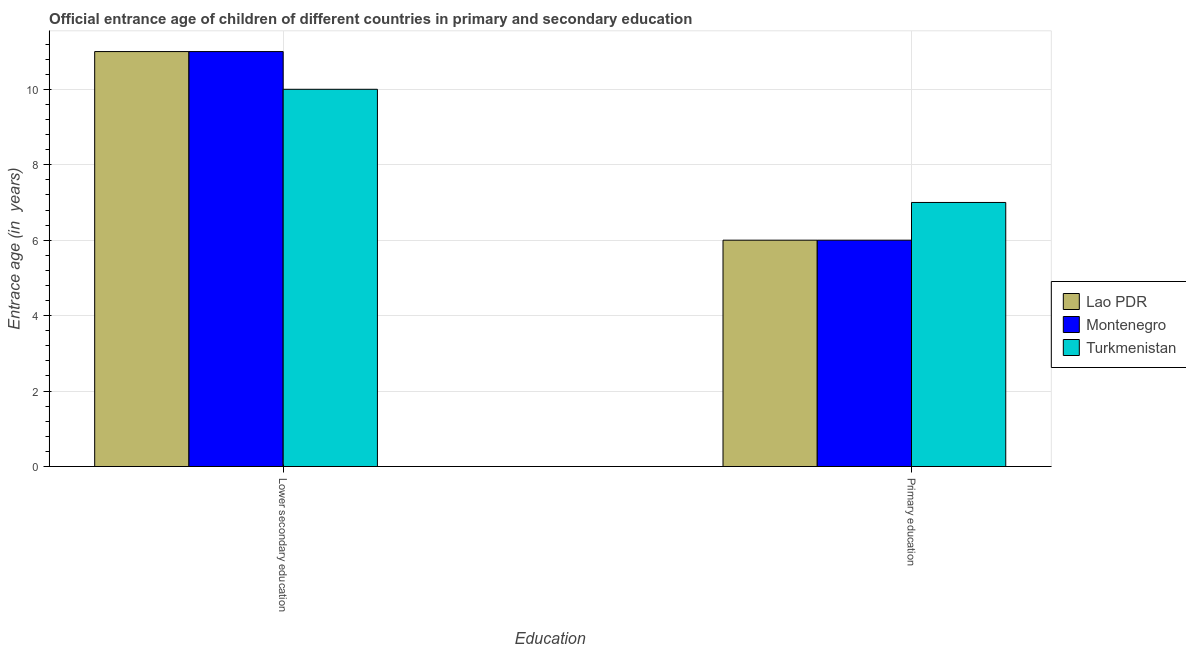How many groups of bars are there?
Ensure brevity in your answer.  2. Are the number of bars per tick equal to the number of legend labels?
Offer a terse response. Yes. Are the number of bars on each tick of the X-axis equal?
Provide a short and direct response. Yes. What is the label of the 1st group of bars from the left?
Ensure brevity in your answer.  Lower secondary education. What is the entrance age of chiildren in primary education in Turkmenistan?
Provide a succinct answer. 7. Across all countries, what is the maximum entrance age of children in lower secondary education?
Your response must be concise. 11. Across all countries, what is the minimum entrance age of children in lower secondary education?
Provide a succinct answer. 10. In which country was the entrance age of chiildren in primary education maximum?
Your answer should be compact. Turkmenistan. In which country was the entrance age of children in lower secondary education minimum?
Keep it short and to the point. Turkmenistan. What is the total entrance age of children in lower secondary education in the graph?
Ensure brevity in your answer.  32. What is the difference between the entrance age of chiildren in primary education in Lao PDR and that in Turkmenistan?
Your response must be concise. -1. What is the difference between the entrance age of children in lower secondary education in Lao PDR and the entrance age of chiildren in primary education in Turkmenistan?
Offer a terse response. 4. What is the average entrance age of children in lower secondary education per country?
Offer a terse response. 10.67. What is the difference between the entrance age of chiildren in primary education and entrance age of children in lower secondary education in Lao PDR?
Provide a succinct answer. -5. What does the 2nd bar from the left in Primary education represents?
Give a very brief answer. Montenegro. What does the 1st bar from the right in Lower secondary education represents?
Offer a very short reply. Turkmenistan. Are all the bars in the graph horizontal?
Keep it short and to the point. No. Are the values on the major ticks of Y-axis written in scientific E-notation?
Offer a very short reply. No. How many legend labels are there?
Keep it short and to the point. 3. What is the title of the graph?
Your response must be concise. Official entrance age of children of different countries in primary and secondary education. Does "Pacific island small states" appear as one of the legend labels in the graph?
Offer a very short reply. No. What is the label or title of the X-axis?
Ensure brevity in your answer.  Education. What is the label or title of the Y-axis?
Your response must be concise. Entrace age (in  years). What is the Entrace age (in  years) of Lao PDR in Lower secondary education?
Keep it short and to the point. 11. What is the Entrace age (in  years) in Montenegro in Lower secondary education?
Offer a very short reply. 11. What is the Entrace age (in  years) of Lao PDR in Primary education?
Ensure brevity in your answer.  6. What is the Entrace age (in  years) in Turkmenistan in Primary education?
Offer a very short reply. 7. Across all Education, what is the maximum Entrace age (in  years) in Lao PDR?
Your response must be concise. 11. Across all Education, what is the maximum Entrace age (in  years) of Montenegro?
Your answer should be compact. 11. Across all Education, what is the maximum Entrace age (in  years) in Turkmenistan?
Provide a short and direct response. 10. Across all Education, what is the minimum Entrace age (in  years) of Lao PDR?
Give a very brief answer. 6. Across all Education, what is the minimum Entrace age (in  years) of Montenegro?
Provide a succinct answer. 6. Across all Education, what is the minimum Entrace age (in  years) in Turkmenistan?
Make the answer very short. 7. What is the total Entrace age (in  years) in Montenegro in the graph?
Keep it short and to the point. 17. What is the difference between the Entrace age (in  years) in Montenegro in Lower secondary education and that in Primary education?
Make the answer very short. 5. What is the difference between the Entrace age (in  years) of Lao PDR in Lower secondary education and the Entrace age (in  years) of Turkmenistan in Primary education?
Your answer should be compact. 4. What is the difference between the Entrace age (in  years) of Montenegro in Lower secondary education and the Entrace age (in  years) of Turkmenistan in Primary education?
Your answer should be compact. 4. What is the average Entrace age (in  years) of Turkmenistan per Education?
Your response must be concise. 8.5. What is the difference between the Entrace age (in  years) in Lao PDR and Entrace age (in  years) in Turkmenistan in Lower secondary education?
Your response must be concise. 1. What is the ratio of the Entrace age (in  years) of Lao PDR in Lower secondary education to that in Primary education?
Offer a very short reply. 1.83. What is the ratio of the Entrace age (in  years) in Montenegro in Lower secondary education to that in Primary education?
Your answer should be very brief. 1.83. What is the ratio of the Entrace age (in  years) of Turkmenistan in Lower secondary education to that in Primary education?
Ensure brevity in your answer.  1.43. What is the difference between the highest and the lowest Entrace age (in  years) of Lao PDR?
Your answer should be very brief. 5. What is the difference between the highest and the lowest Entrace age (in  years) of Montenegro?
Provide a succinct answer. 5. What is the difference between the highest and the lowest Entrace age (in  years) of Turkmenistan?
Your response must be concise. 3. 